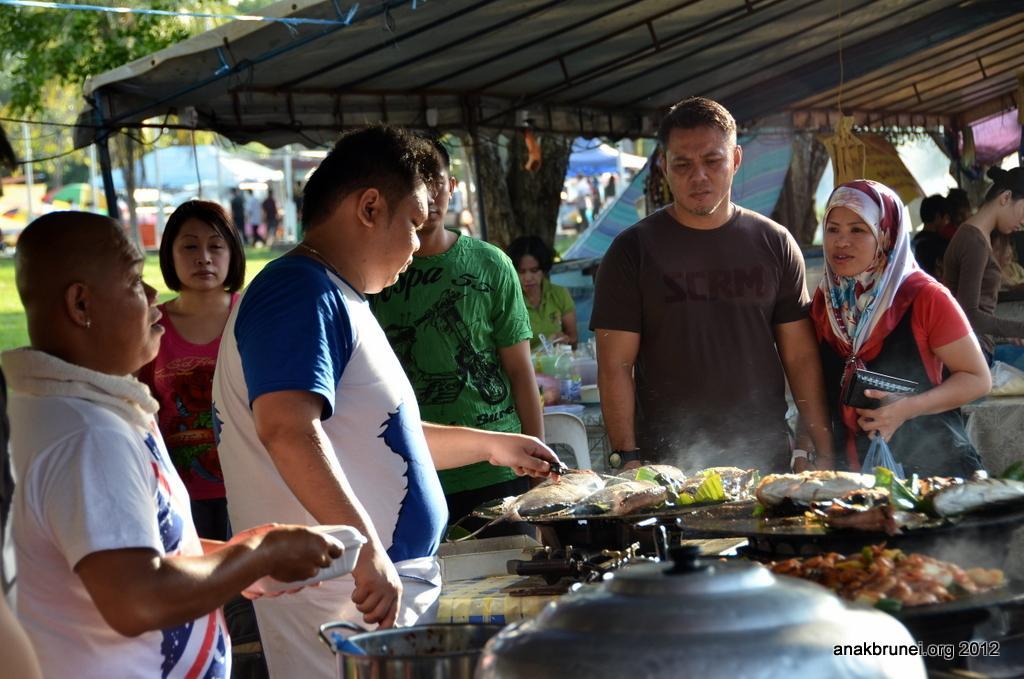Could you give a brief overview of what you see in this image? As we can see in the image there are few people here and there, gas stove, tents, grass, trees and dish. 